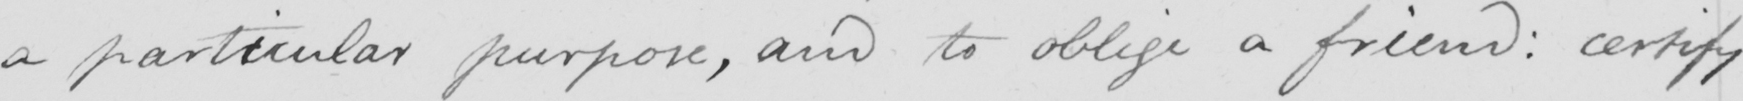Transcribe the text shown in this historical manuscript line. a particular purpose, and to oblige a friend: certify 